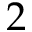<formula> <loc_0><loc_0><loc_500><loc_500>2</formula> 